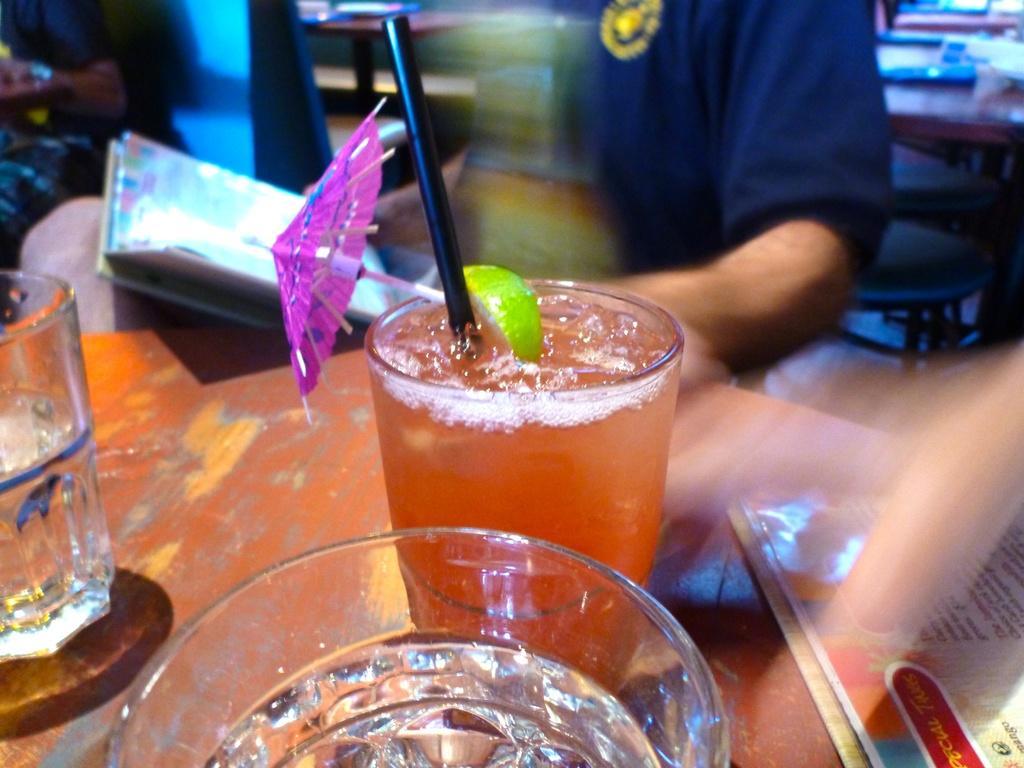Describe this image in one or two sentences. In this image in front there is a table and on top of the table there are three glasses and a menu card where on one glass there is orange juice and on another two glasses there is a water. Behind the table there is a person sitting on the chair by holding the book. Beside him there is a another person sitting on the chair. Behind the person there is a chair and a table. 